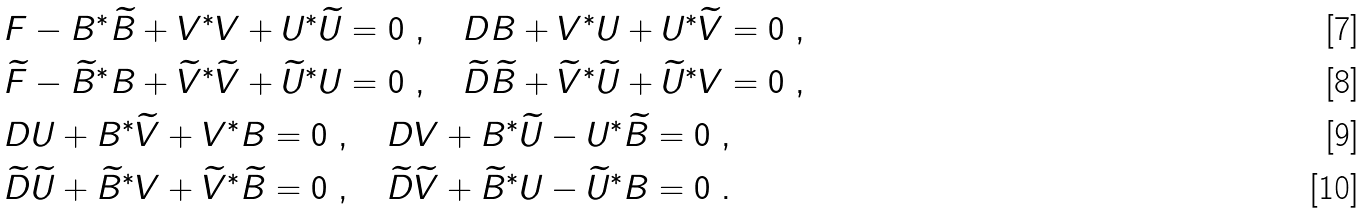Convert formula to latex. <formula><loc_0><loc_0><loc_500><loc_500>& F - B ^ { * } \widetilde { B } + V ^ { * } V + U ^ { * } \widetilde { U } = 0 \ , \quad D B + V ^ { * } U + U ^ { * } \widetilde { V } = 0 \ , \\ & \widetilde { F } - \widetilde { B } ^ { * } B + \widetilde { V } ^ { * } \widetilde { V } + \widetilde { U } ^ { * } U = 0 \ , \quad \widetilde { D } \widetilde { B } + \widetilde { V } ^ { * } \widetilde { U } + \widetilde { U } ^ { * } V = 0 \ , \\ & D U + B ^ { * } \widetilde { V } + V ^ { * } B = 0 \ , \quad D V + B ^ { * } \widetilde { U } - U ^ { * } \widetilde { B } = 0 \ , \\ & \widetilde { D } \widetilde { U } + \widetilde { B } ^ { * } V + \widetilde { V } ^ { * } \widetilde { B } = 0 \ , \quad \widetilde { D } \widetilde { V } + \widetilde { B } ^ { * } U - \widetilde { U } ^ { * } B = 0 \ .</formula> 